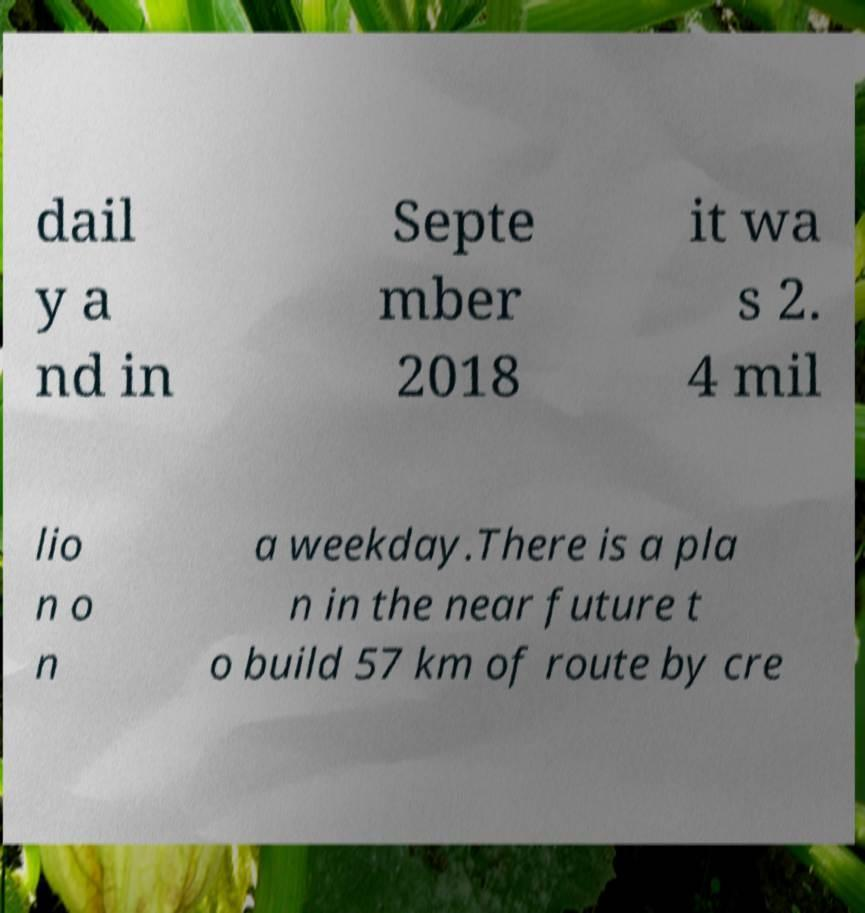I need the written content from this picture converted into text. Can you do that? dail y a nd in Septe mber 2018 it wa s 2. 4 mil lio n o n a weekday.There is a pla n in the near future t o build 57 km of route by cre 